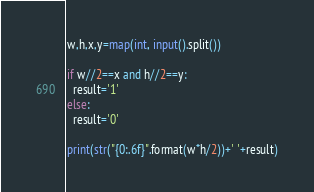<code> <loc_0><loc_0><loc_500><loc_500><_Python_>w,h,x,y=map(int, input().split())

if w//2==x and h//2==y:
  result='1'
else:
  result='0'

print(str("{0:.6f}".format(w*h/2))+' '+result)</code> 